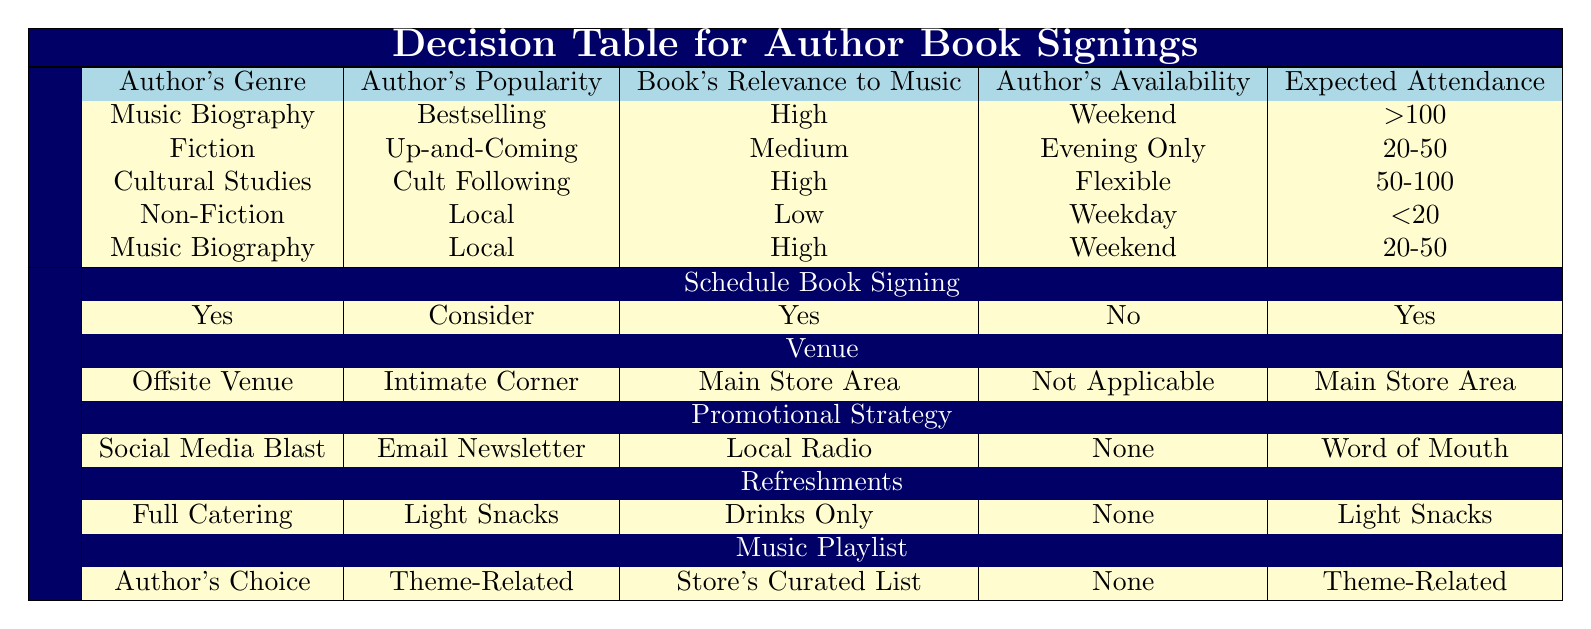What conditions lead to scheduling a book signing? From the decision table, there are four conditions where a book signing is scheduled: Music Biography with bestselling popularity, Cultural Studies with a cult following, Music Biography with local popularity, and Fiction with an up-and-coming status.
Answer: Four conditions What is the venue for a bestselling author whose book has high relevance to music? According to the table, a bestselling author with high relevance to music and a genre of Music Biography will have the venue as an offsite venue.
Answer: Offsite Venue Is there a specific author genre that guarantees a book signing? The table shows that Music Biography with bestselling popularity guarantees a book signing, while Non-Fiction with local popularity does not.
Answer: Yes, Music Biography Which promotional strategy is associated with Cultural Studies authors with a cult following? The table indicates that when the author is from Cultural Studies, has a cult following, and meets the other conditions, the promotional strategy will be local radio.
Answer: Local Radio How many authors with high relevance to music and flexible availability are scheduled for book signings? The table shows one author (Cultural Studies with a cult following) fits the criteria of high relevance to music and flexible availability, which is scheduled for book signing.
Answer: One author What is the most common expected attendance range for authors scheduled for signings? By reviewing the rows, there are two instances of attendance expected at 50-100 (Cultural Studies and Music Biography, Local), and two instances below that (20-50 and <20). The highest attendance is >100, which only occurs once. Since the most frequent expected attendance is seen in the two rows, we can conclude that the common range is 50-100.
Answer: 50-100 For an up-and-coming fiction author with medium relevance to music, what type of refreshments can be expected? The table states that an up-and-coming fiction author will have light snacks as the refreshments if scheduled.
Answer: Light Snacks What can be inferred about scheduling signings for local authors from the table? The table shows that local authors with a low relevance to music on weekdays won't be scheduled, while local authors with high relevance to music on weekends can be scheduled. This implies that local authors are only suitable for signings if they meet specific conditions.
Answer: Specific conditions must be met What would be the venue for a high attendance event that isn't focused on Music Biography? According to the table, there are no high attendance conditions specified for genres other than Music Biography that fit those parameters. Thus, this type of event with those conditions cannot occur.
Answer: Not applicable 